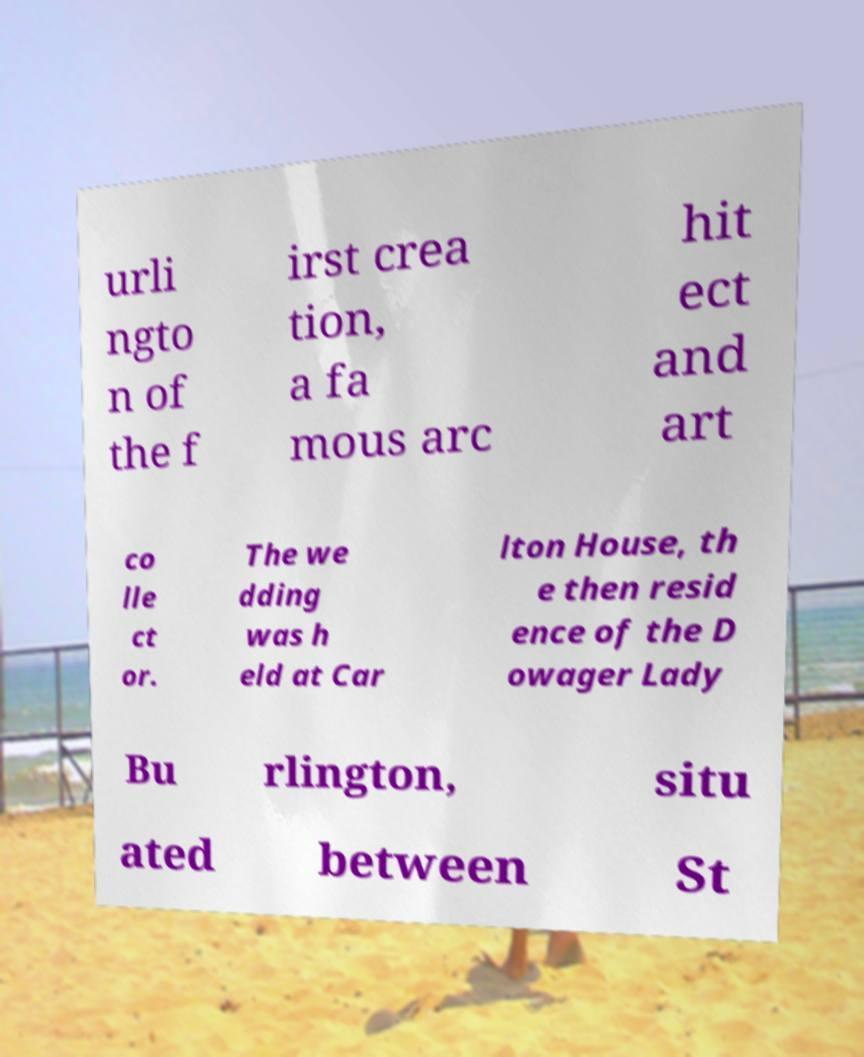Can you accurately transcribe the text from the provided image for me? urli ngto n of the f irst crea tion, a fa mous arc hit ect and art co lle ct or. The we dding was h eld at Car lton House, th e then resid ence of the D owager Lady Bu rlington, situ ated between St 